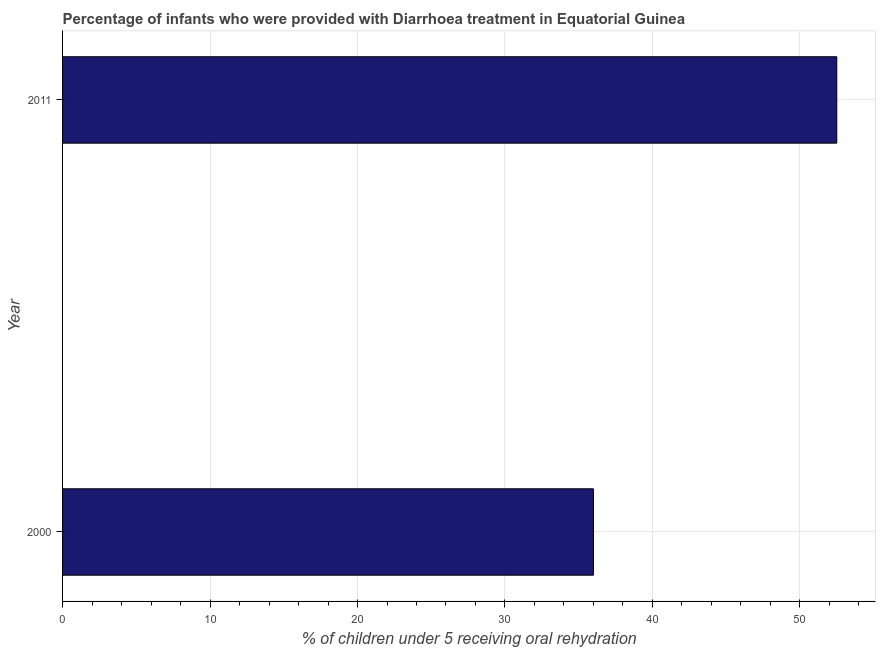What is the title of the graph?
Give a very brief answer. Percentage of infants who were provided with Diarrhoea treatment in Equatorial Guinea. What is the label or title of the X-axis?
Ensure brevity in your answer.  % of children under 5 receiving oral rehydration. What is the percentage of children who were provided with treatment diarrhoea in 2011?
Give a very brief answer. 52.5. Across all years, what is the maximum percentage of children who were provided with treatment diarrhoea?
Keep it short and to the point. 52.5. Across all years, what is the minimum percentage of children who were provided with treatment diarrhoea?
Offer a terse response. 36. In which year was the percentage of children who were provided with treatment diarrhoea minimum?
Your answer should be compact. 2000. What is the sum of the percentage of children who were provided with treatment diarrhoea?
Provide a succinct answer. 88.5. What is the difference between the percentage of children who were provided with treatment diarrhoea in 2000 and 2011?
Provide a succinct answer. -16.5. What is the average percentage of children who were provided with treatment diarrhoea per year?
Offer a very short reply. 44.25. What is the median percentage of children who were provided with treatment diarrhoea?
Ensure brevity in your answer.  44.25. In how many years, is the percentage of children who were provided with treatment diarrhoea greater than 16 %?
Give a very brief answer. 2. Do a majority of the years between 2000 and 2011 (inclusive) have percentage of children who were provided with treatment diarrhoea greater than 6 %?
Offer a terse response. Yes. What is the ratio of the percentage of children who were provided with treatment diarrhoea in 2000 to that in 2011?
Give a very brief answer. 0.69. In how many years, is the percentage of children who were provided with treatment diarrhoea greater than the average percentage of children who were provided with treatment diarrhoea taken over all years?
Make the answer very short. 1. What is the difference between two consecutive major ticks on the X-axis?
Provide a succinct answer. 10. Are the values on the major ticks of X-axis written in scientific E-notation?
Ensure brevity in your answer.  No. What is the % of children under 5 receiving oral rehydration in 2011?
Your answer should be compact. 52.5. What is the difference between the % of children under 5 receiving oral rehydration in 2000 and 2011?
Provide a short and direct response. -16.5. What is the ratio of the % of children under 5 receiving oral rehydration in 2000 to that in 2011?
Your answer should be compact. 0.69. 